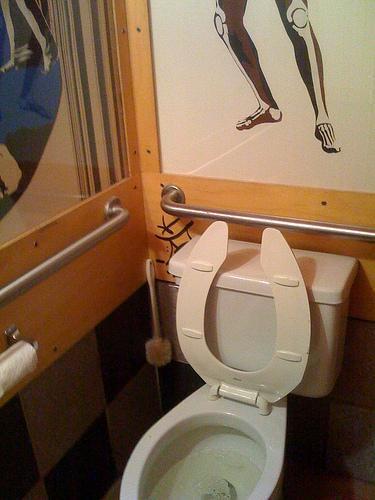How many toilet brushes are there?
Give a very brief answer. 1. How many metal handles are there?
Give a very brief answer. 2. How many rolls of toilet paper are there?
Give a very brief answer. 1. 